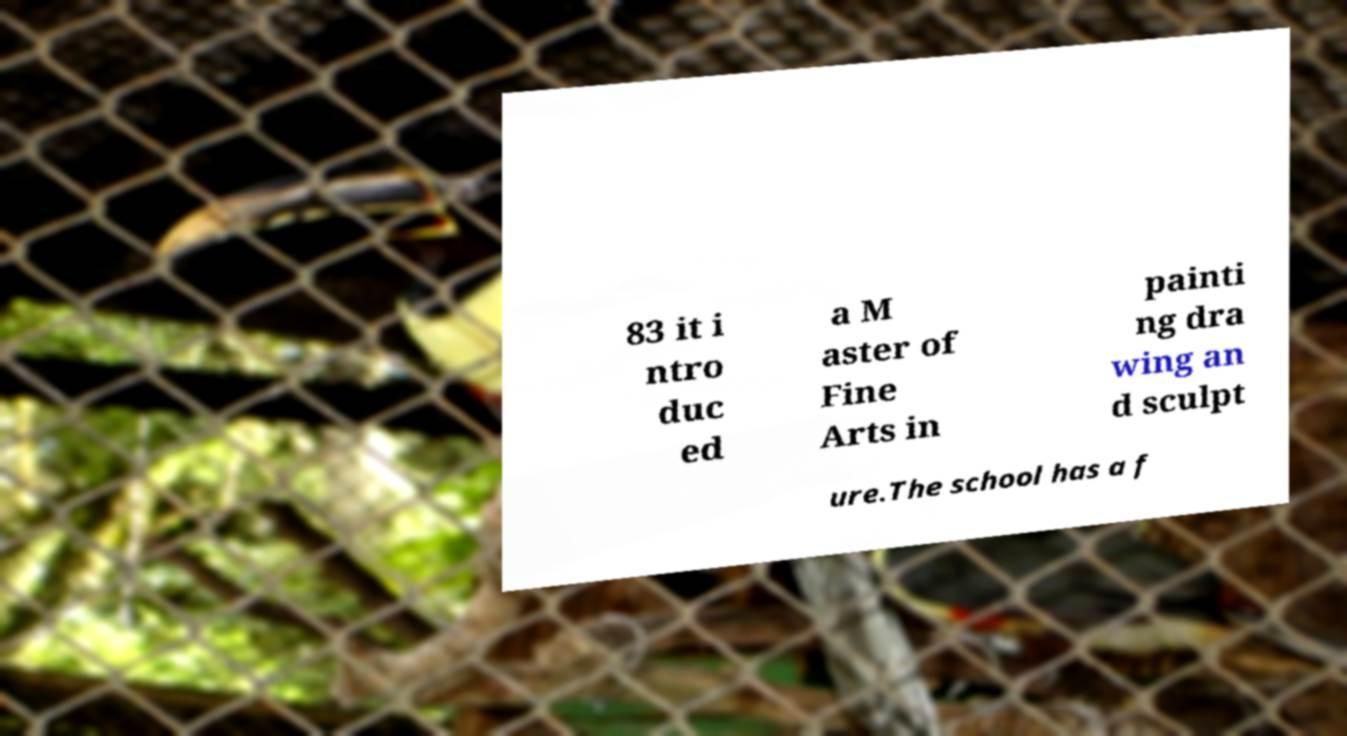I need the written content from this picture converted into text. Can you do that? 83 it i ntro duc ed a M aster of Fine Arts in painti ng dra wing an d sculpt ure.The school has a f 